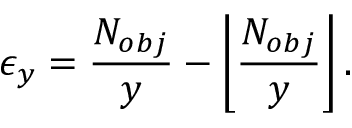Convert formula to latex. <formula><loc_0><loc_0><loc_500><loc_500>\epsilon _ { y } = \frac { N _ { o b j } } { y } - \left \lfloor \frac { N _ { o b j } } { y } \right \rfloor .</formula> 